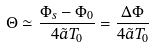<formula> <loc_0><loc_0><loc_500><loc_500>\Theta \simeq \frac { \Phi _ { s } - \Phi _ { 0 } } { 4 \tilde { a } T _ { 0 } } = \frac { \Delta \Phi } { 4 \tilde { a } T _ { 0 } }</formula> 